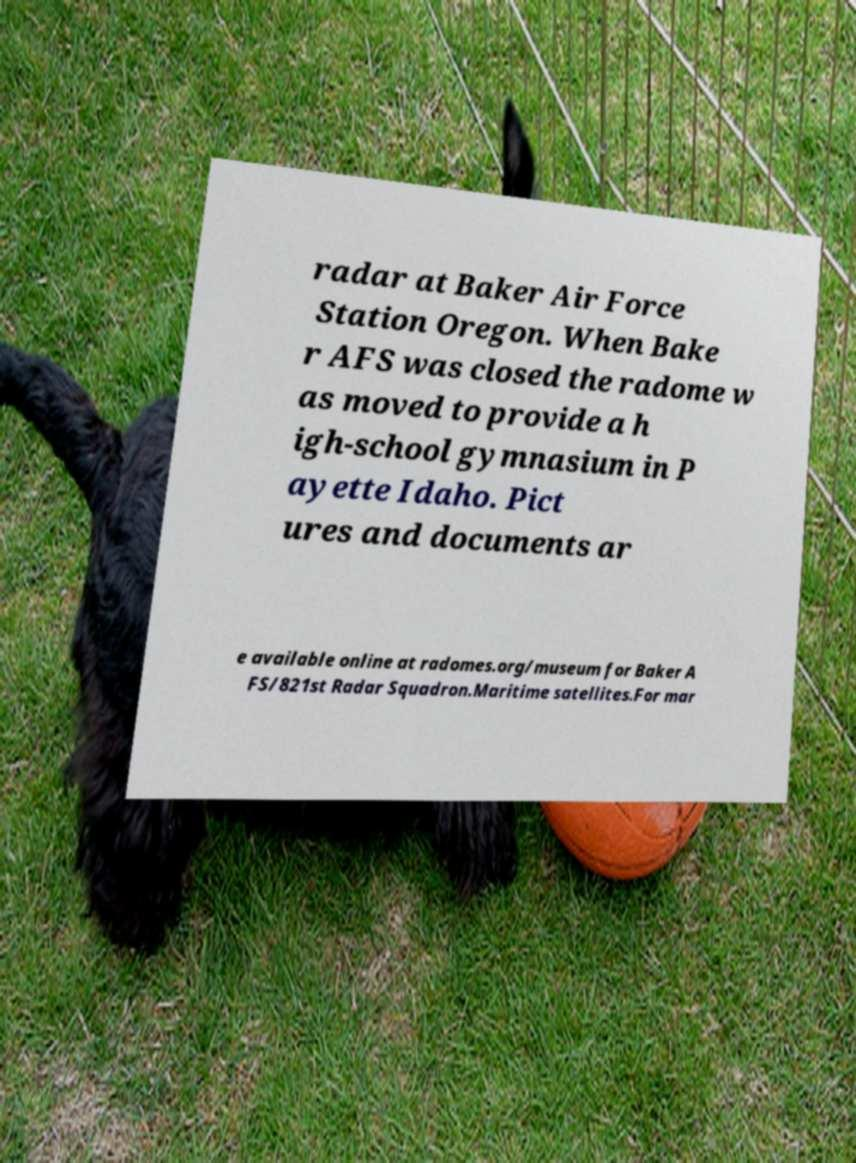There's text embedded in this image that I need extracted. Can you transcribe it verbatim? radar at Baker Air Force Station Oregon. When Bake r AFS was closed the radome w as moved to provide a h igh-school gymnasium in P ayette Idaho. Pict ures and documents ar e available online at radomes.org/museum for Baker A FS/821st Radar Squadron.Maritime satellites.For mar 